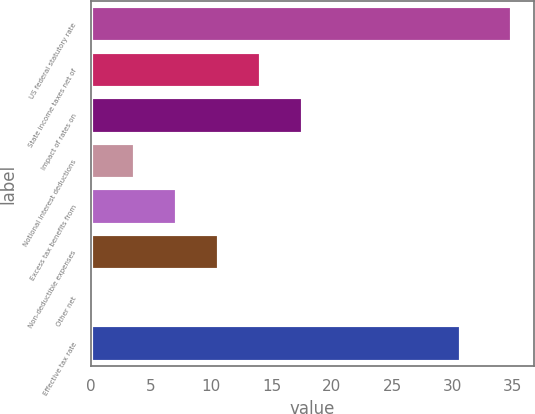Convert chart to OTSL. <chart><loc_0><loc_0><loc_500><loc_500><bar_chart><fcel>US federal statutory rate<fcel>State income taxes net of<fcel>Impact of rates on<fcel>Notional interest deductions<fcel>Excess tax benefits from<fcel>Non-deductible expenses<fcel>Other net<fcel>Effective tax rate<nl><fcel>35<fcel>14.12<fcel>17.6<fcel>3.68<fcel>7.16<fcel>10.64<fcel>0.2<fcel>30.7<nl></chart> 